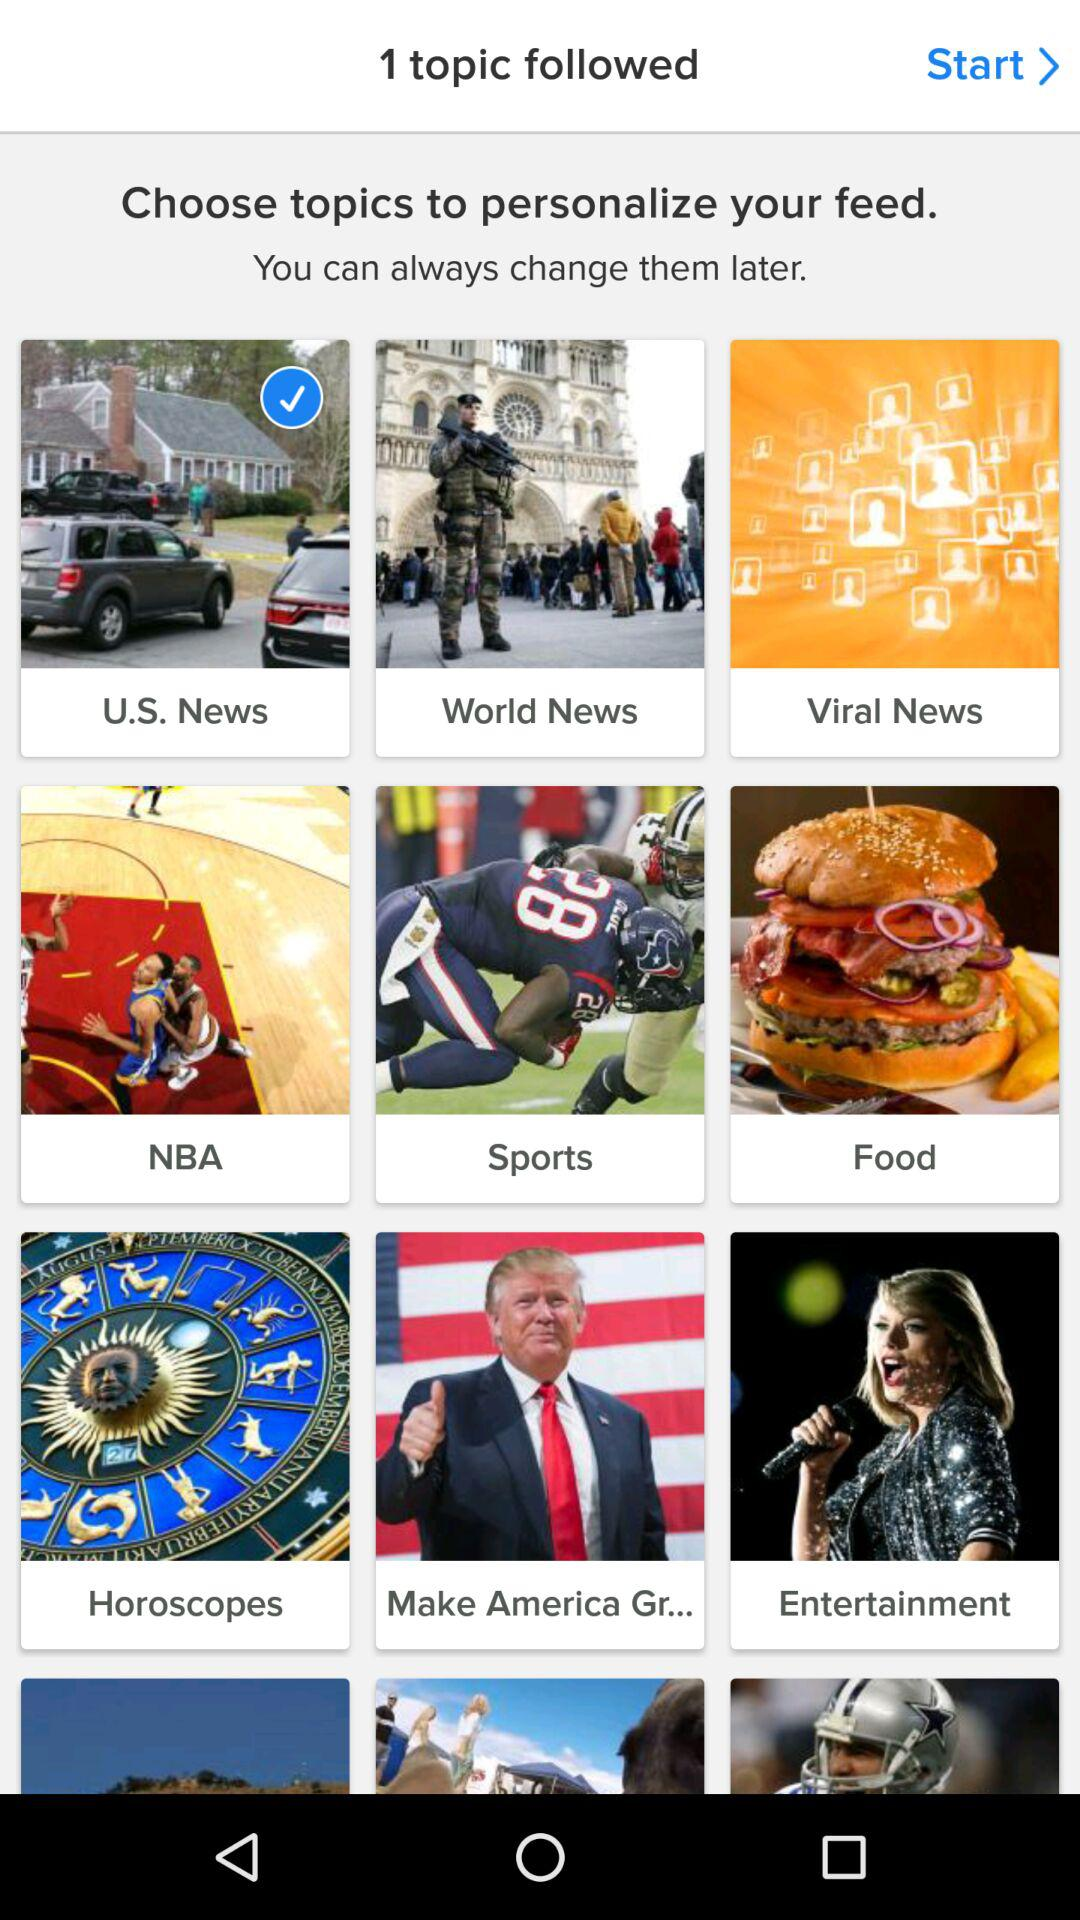Which topic is being followed? The followed topic is "U.S. news". 